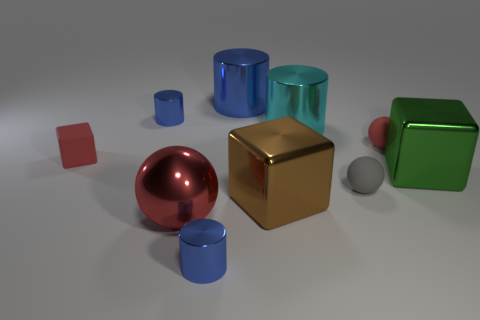Subtract all blue cylinders. How many were subtracted if there are1blue cylinders left? 2 Subtract all green balls. How many blue cylinders are left? 3 Subtract all cylinders. How many objects are left? 6 Add 9 large blue cylinders. How many large blue cylinders are left? 10 Add 5 blue metal objects. How many blue metal objects exist? 8 Subtract 0 blue spheres. How many objects are left? 10 Subtract all big shiny cylinders. Subtract all red shiny objects. How many objects are left? 7 